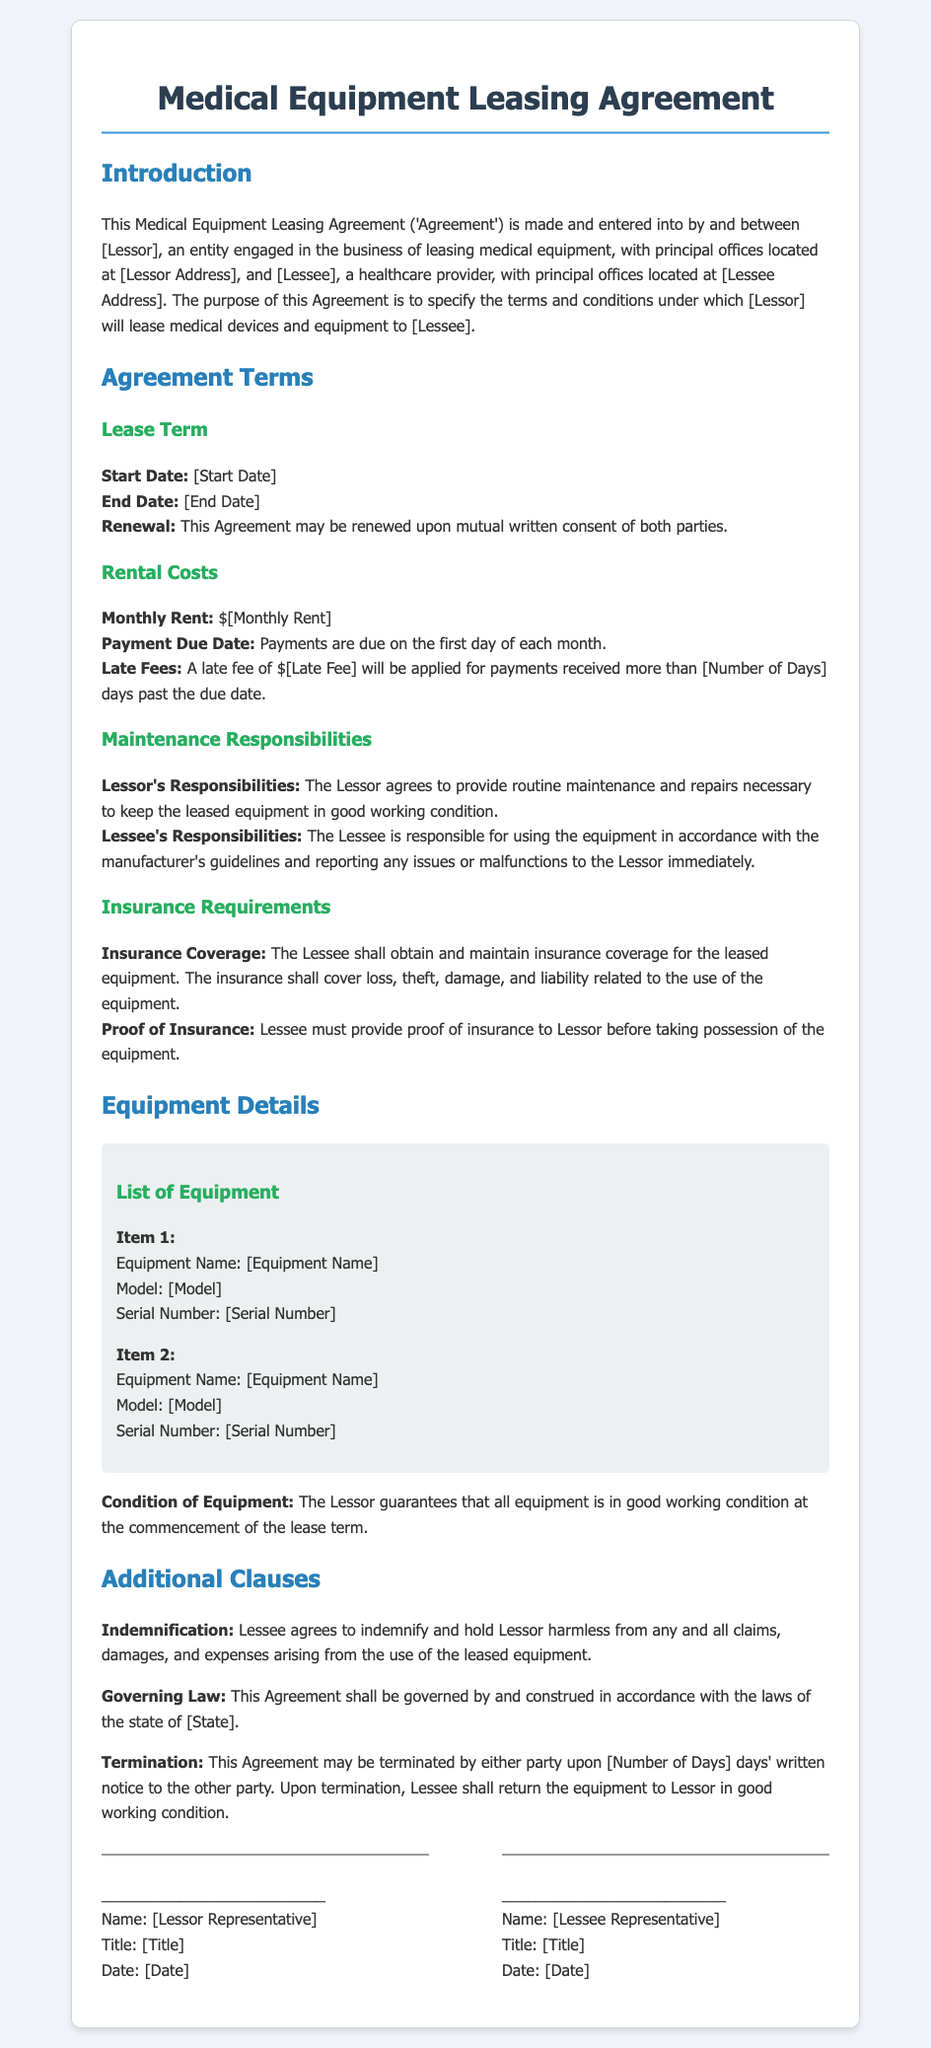What is the lease term start date? The start date is specified in the document under the Lease Term section, which is labeled as Start Date.
Answer: [Start Date] What is the monthly rent amount? The monthly rent value is indicated in the Rental Costs section where it states the amount required as Monthly Rent.
Answer: $[Monthly Rent] What is the late fee for overdue payments? The late fee is mentioned in the Rental Costs section, detailing the amount applied for late payments.
Answer: $[Late Fee] Who is responsible for routine maintenance? Responsibilities for maintenance are divided between parties, specifically stated in the Maintenance Responsibilities section, mentioning that the Lessor is responsible.
Answer: Lessor What must the Lessee provide before taking possession of the equipment? The requirement for proof of insurance is highlighted under the Insurance Requirements section, indicating what documentation must be provided.
Answer: Proof of Insurance How many days notice is needed for termination? The termination notice period is specified in the Additional Clauses section, indicating how many days' notice is required.
Answer: [Number of Days] What type of law governs this Agreement? The governing law is noted in the Additional Clauses section, identifying the type of legal jurisdiction applicable to the Agreement.
Answer: [State] What must the Lessee do if equipment is damaged? The indemnification clause outlines Lessee's obligations concerning claims or damages that arise from equipment use, indicating action is needed.
Answer: Indemnify What condition does the Lessor guarantee for the equipment? The condition of the equipment is guaranteed by the Lessor as stated in the Equipment Details section regarding its operational state.
Answer: Good working condition 